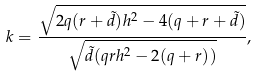<formula> <loc_0><loc_0><loc_500><loc_500>k = \frac { \sqrt { 2 q ( r + { \tilde { d } } ) h ^ { 2 } - 4 ( q + r + { \tilde { d } } ) } } { \sqrt { { \tilde { d } } ( q r h ^ { 2 } - 2 ( q + r ) ) } } ,</formula> 